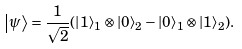Convert formula to latex. <formula><loc_0><loc_0><loc_500><loc_500>\left | \psi \right \rangle = \frac { 1 } { \sqrt { 2 } } ( \left | 1 \right \rangle _ { 1 } \otimes \left | 0 \right \rangle _ { 2 } - \left | 0 \right \rangle _ { 1 } \otimes \left | 1 \right \rangle _ { 2 } ) .</formula> 